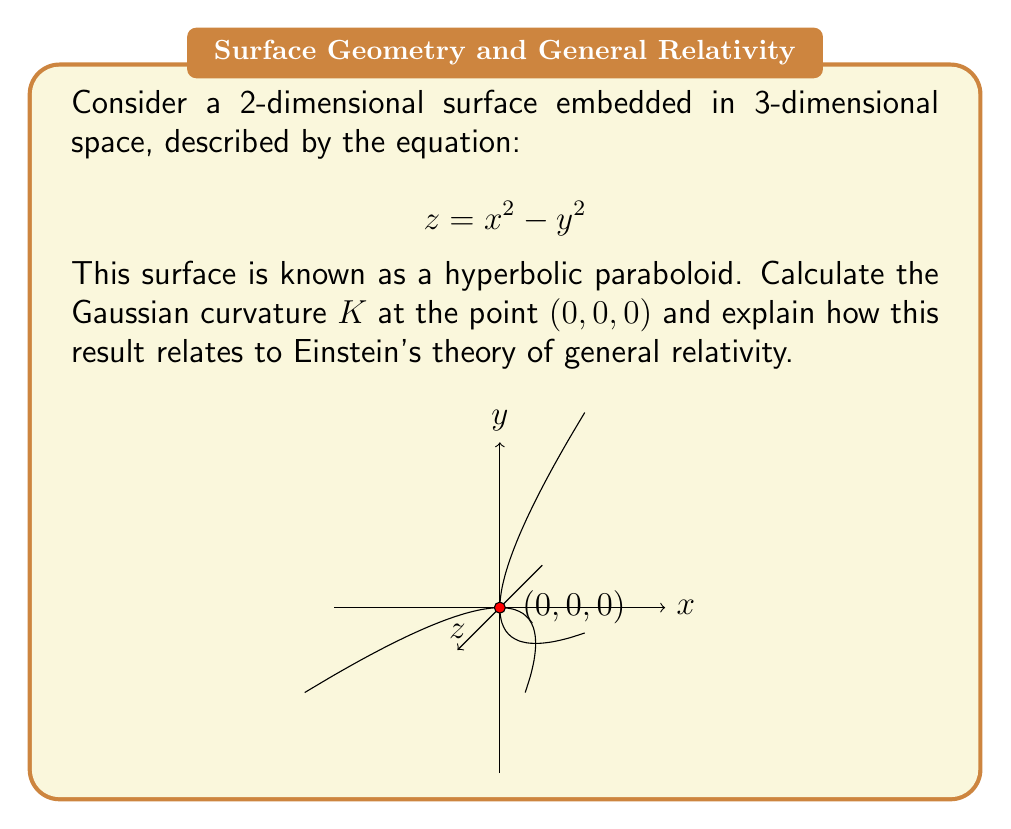Teach me how to tackle this problem. To calculate the Gaussian curvature and relate it to general relativity, we'll follow these steps:

1) The Gaussian curvature $K$ is given by the product of the principal curvatures: $K = \kappa_1 \kappa_2$

2) For a surface $z = f(x,y)$, the Gaussian curvature at a point is given by:

   $$K = \frac{f_{xx}f_{yy} - f_{xy}^2}{(1 + f_x^2 + f_y^2)^2}$$

   where subscripts denote partial derivatives.

3) For our surface $z = x^2 - y^2$:
   $f_x = 2x$, $f_y = -2y$
   $f_{xx} = 2$, $f_{yy} = -2$, $f_{xy} = 0$

4) At the point $(0,0,0)$:
   $f_x = f_y = 0$
   $f_{xx} = 2$, $f_{yy} = -2$, $f_{xy} = 0$

5) Substituting into the curvature formula:

   $$K = \frac{(2)(-2) - 0^2}{(1 + 0^2 + 0^2)^2} = -4$$

6) The negative Gaussian curvature indicates that this is a saddle point, where the surface curves upward in one direction and downward in the perpendicular direction.

7) In general relativity, the curvature of spacetime is described by the Riemann curvature tensor. The Gaussian curvature is analogous to the scalar curvature in general relativity, which is a contraction of the Riemann tensor.

8) Just as the hyperbolic paraboloid has non-zero curvature at $(0,0,0)$, spacetime in general relativity can have non-zero curvature due to the presence of matter and energy. This curvature is what we perceive as gravity.

9) The negative curvature we found is similar to how certain mass distributions in general relativity can create regions of negative curvature, potentially leading to phenomena like gravitational lensing.
Answer: $K = -4$ at $(0,0,0)$; negative curvature analogous to spacetime curvature in general relativity. 